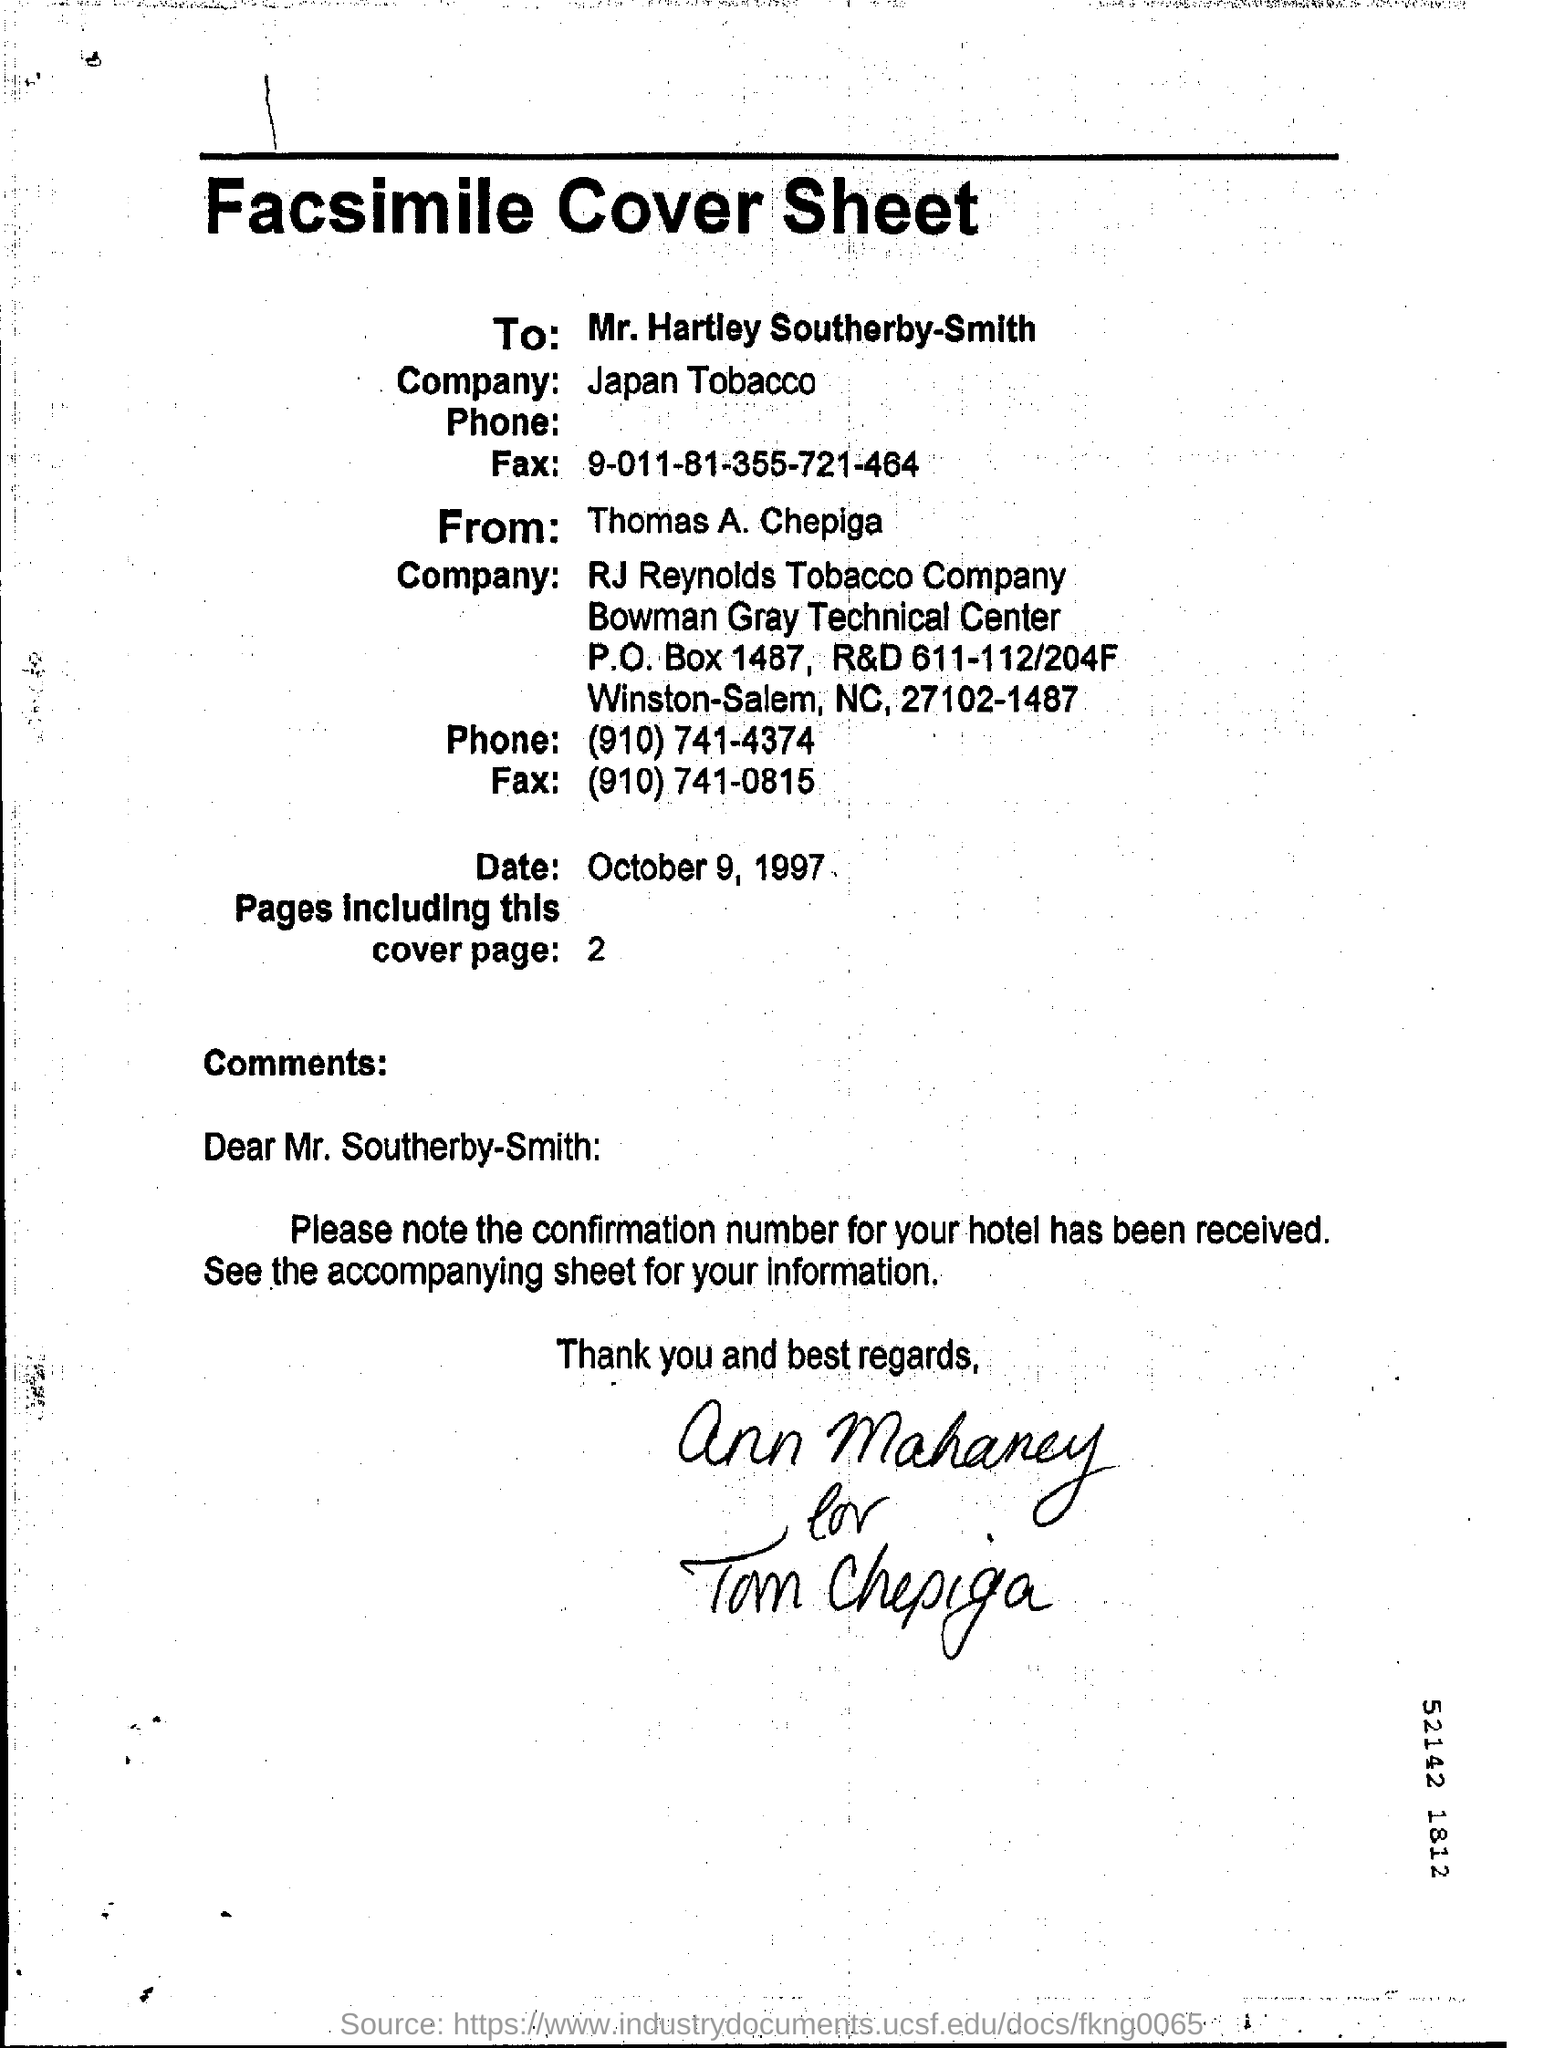Give some essential details in this illustration. The company named Japan Tobacco is mentioned in the cover sheet. The heading of the cover sheet for the document is a facsimile. The person named in the facsimile cover sheet is Thomas A. Chepiga. There are 2 pages included in the cover page. The addressee of the comments is Mr. Southerby-Smith. 